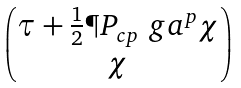Convert formula to latex. <formula><loc_0><loc_0><loc_500><loc_500>\begin{pmatrix} \tau + \frac { 1 } { 2 } \P P _ { c p } \ g a ^ { p } \chi \\ \chi \end{pmatrix}</formula> 